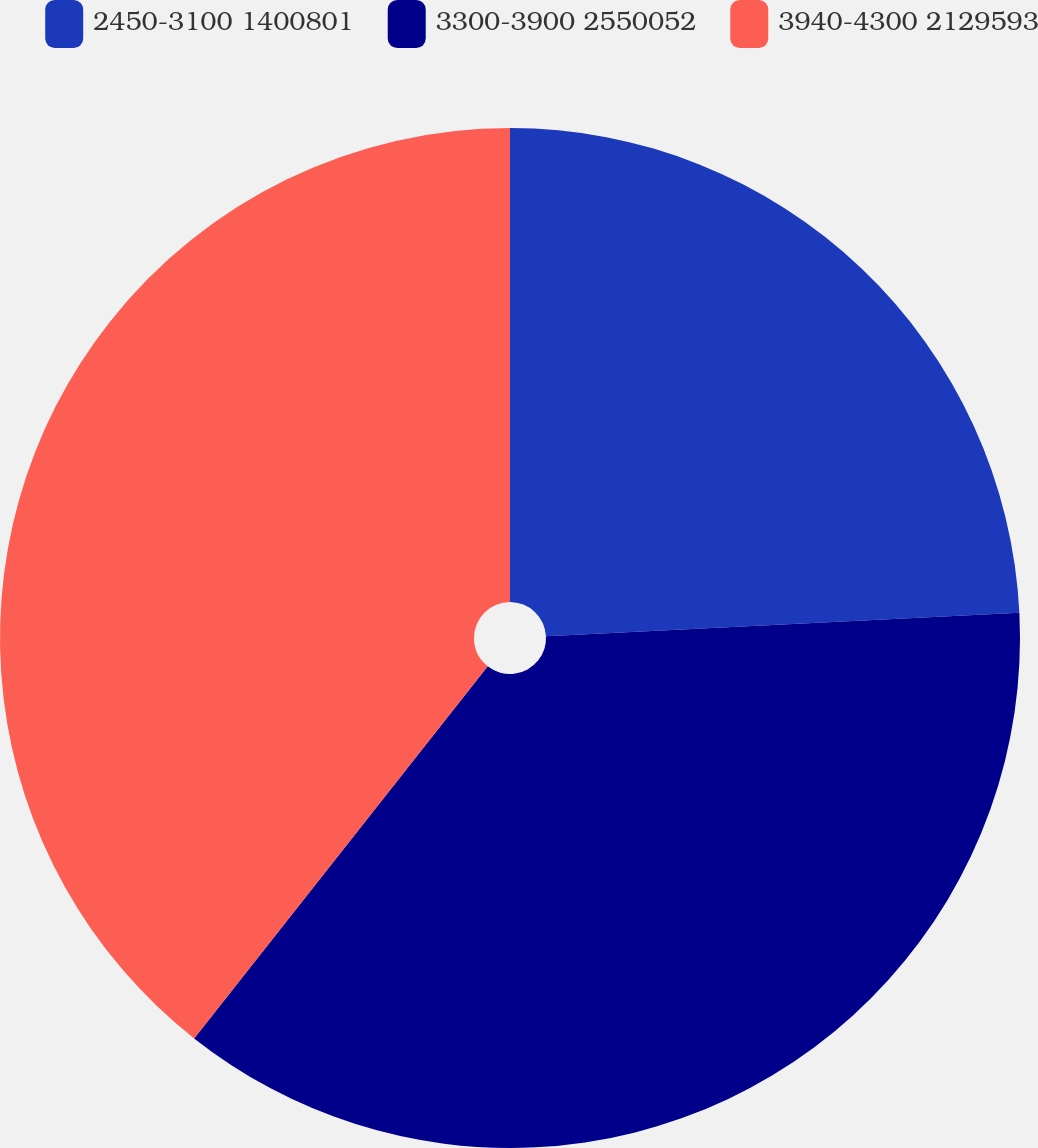Convert chart to OTSL. <chart><loc_0><loc_0><loc_500><loc_500><pie_chart><fcel>2450-3100 1400801<fcel>3300-3900 2550052<fcel>3940-4300 2129593<nl><fcel>24.21%<fcel>36.42%<fcel>39.37%<nl></chart> 